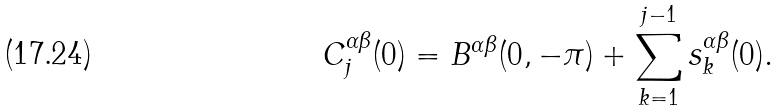<formula> <loc_0><loc_0><loc_500><loc_500>C _ { j } ^ { \alpha \beta } ( 0 ) = B ^ { \alpha \beta } ( 0 , - \pi ) + \sum _ { k = 1 } ^ { j - 1 } s _ { k } ^ { \alpha \beta } ( 0 ) .</formula> 